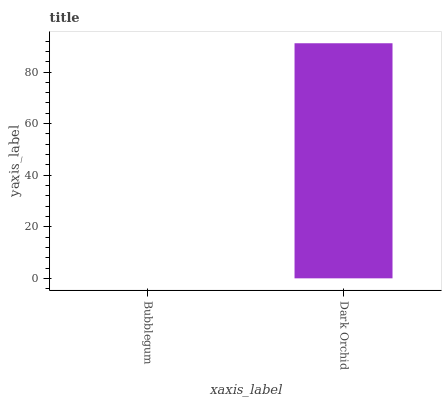Is Bubblegum the minimum?
Answer yes or no. Yes. Is Dark Orchid the maximum?
Answer yes or no. Yes. Is Dark Orchid the minimum?
Answer yes or no. No. Is Dark Orchid greater than Bubblegum?
Answer yes or no. Yes. Is Bubblegum less than Dark Orchid?
Answer yes or no. Yes. Is Bubblegum greater than Dark Orchid?
Answer yes or no. No. Is Dark Orchid less than Bubblegum?
Answer yes or no. No. Is Dark Orchid the high median?
Answer yes or no. Yes. Is Bubblegum the low median?
Answer yes or no. Yes. Is Bubblegum the high median?
Answer yes or no. No. Is Dark Orchid the low median?
Answer yes or no. No. 